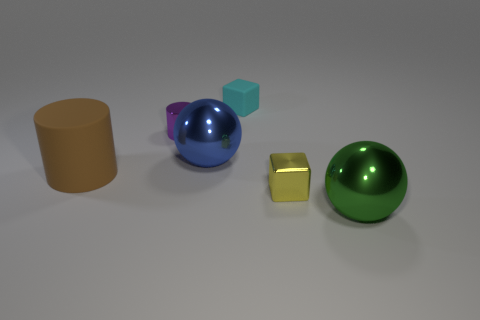There is a rubber thing that is the same shape as the tiny yellow shiny thing; what is its size?
Provide a succinct answer. Small. How big is the block right of the object that is behind the purple object?
Your response must be concise. Small. Are there an equal number of large rubber cylinders right of the yellow metal block and metal spheres?
Provide a short and direct response. No. Are there fewer small rubber blocks left of the green ball than large green matte things?
Your answer should be compact. No. Is there a purple cylinder that has the same size as the rubber cube?
Provide a succinct answer. Yes. There is a metal ball right of the small cyan rubber cube; what number of shiny balls are behind it?
Your answer should be very brief. 1. There is a metallic ball behind the object to the left of the tiny purple object; what color is it?
Make the answer very short. Blue. What material is the big thing that is both right of the purple shiny cylinder and to the left of the small metal block?
Keep it short and to the point. Metal. Is there a big brown matte object that has the same shape as the purple object?
Your answer should be very brief. Yes. Is the shape of the purple object that is to the left of the big green thing the same as  the cyan object?
Give a very brief answer. No. 